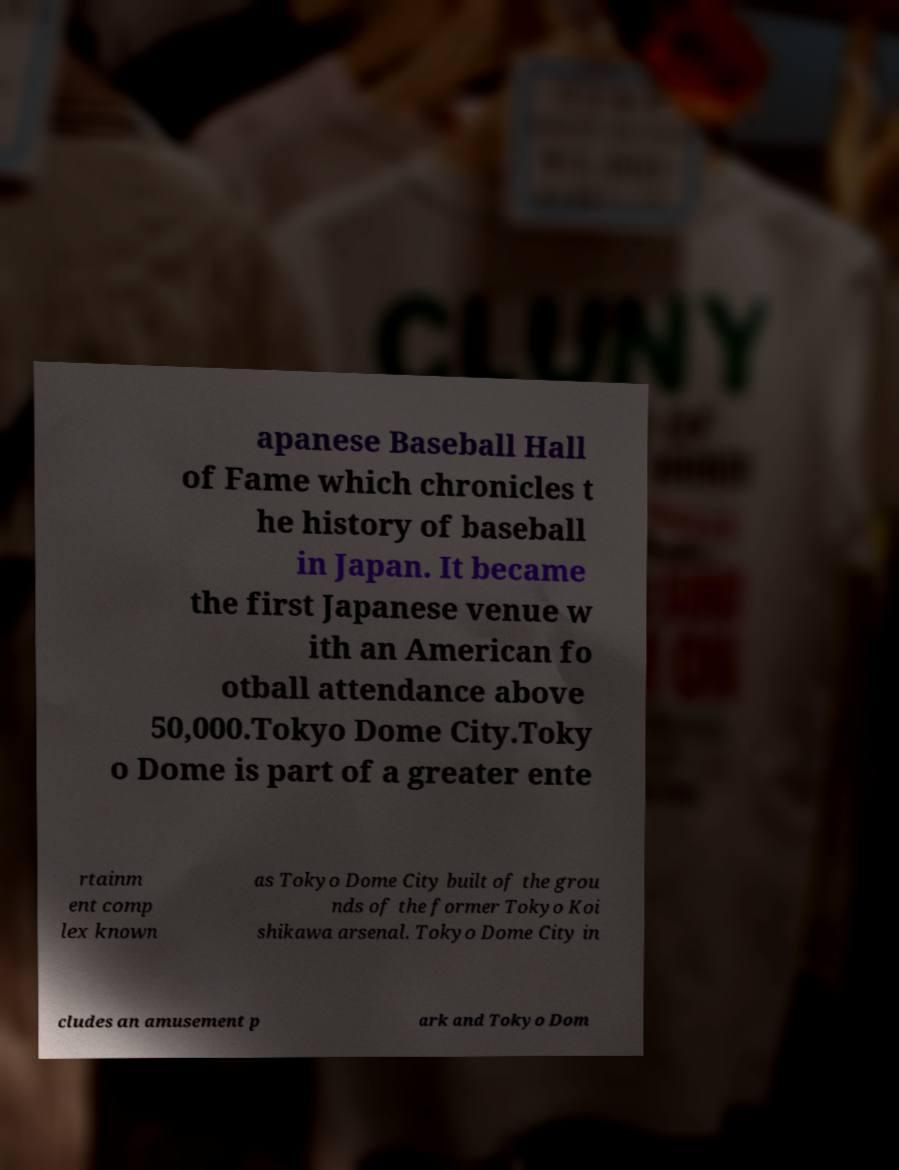For documentation purposes, I need the text within this image transcribed. Could you provide that? apanese Baseball Hall of Fame which chronicles t he history of baseball in Japan. It became the first Japanese venue w ith an American fo otball attendance above 50,000.Tokyo Dome City.Toky o Dome is part of a greater ente rtainm ent comp lex known as Tokyo Dome City built of the grou nds of the former Tokyo Koi shikawa arsenal. Tokyo Dome City in cludes an amusement p ark and Tokyo Dom 